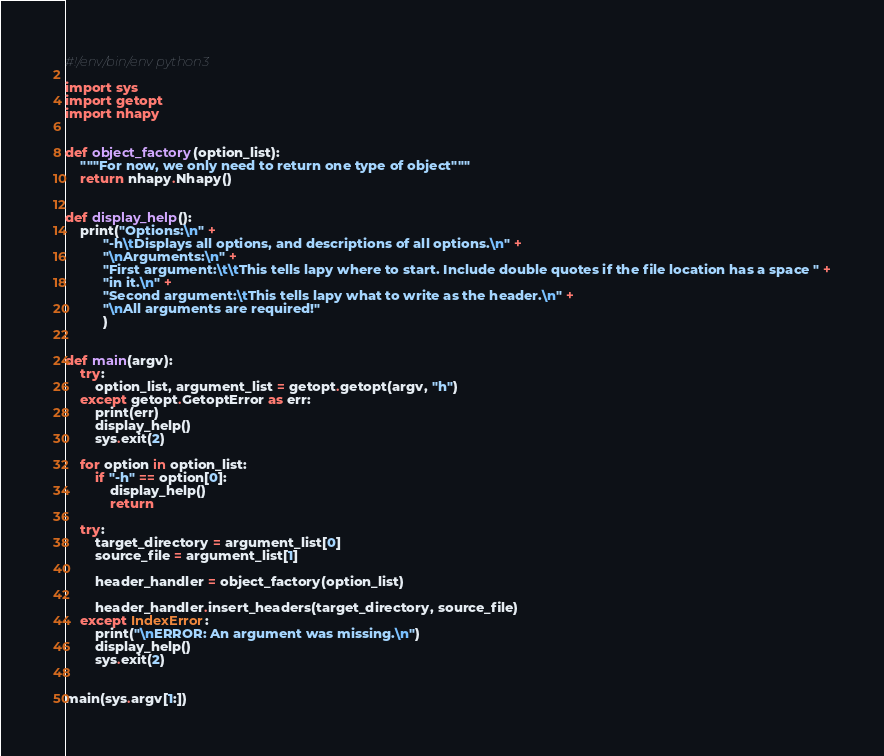Convert code to text. <code><loc_0><loc_0><loc_500><loc_500><_Python_>#!/env/bin/env python3

import sys
import getopt
import nhapy


def object_factory(option_list):
    """For now, we only need to return one type of object"""
    return nhapy.Nhapy()


def display_help():
    print("Options:\n" +
          "-h\tDisplays all options, and descriptions of all options.\n" +
          "\nArguments:\n" +
          "First argument:\t\tThis tells lapy where to start. Include double quotes if the file location has a space " +
          "in it.\n" +
          "Second argument:\tThis tells lapy what to write as the header.\n" +
          "\nAll arguments are required!"
          )


def main(argv):
    try:
        option_list, argument_list = getopt.getopt(argv, "h")
    except getopt.GetoptError as err:
        print(err)
        display_help()
        sys.exit(2)

    for option in option_list:
        if "-h" == option[0]:
            display_help()
            return

    try:
        target_directory = argument_list[0]
        source_file = argument_list[1]

        header_handler = object_factory(option_list)

        header_handler.insert_headers(target_directory, source_file)
    except IndexError:
        print("\nERROR: An argument was missing.\n")
        display_help()
        sys.exit(2)


main(sys.argv[1:])
</code> 